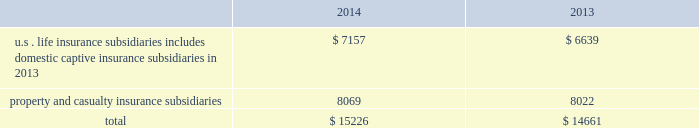The agencies consider many factors in determining the final rating of an insurance company .
One consideration is the relative level of statutory surplus necessary to support the business written .
Statutory surplus represents the capital of the insurance company reported in accordance with accounting practices prescribed by the applicable state insurance department .
See part i , item 1a .
Risk factors 2014 201cdowngrades in our financial strength or credit ratings , which may make our products less attractive , could increase our cost of capital and inhibit our ability to refinance our debt , which would have a material adverse effect on our business , financial condition , results of operations and liquidity . 201d statutory surplus the table below sets forth statutory surplus for the company 2019s insurance companies as of december 31 , 2014 and 2013: .
Statutory capital and surplus for the u.s .
Life insurance subsidiaries , including domestic captive insurance subsidiaries in 2013 , increased by $ 518 , primarily due to variable annuity surplus impacts of $ 788 , net income from non-variable annuity business of $ 187 , increases in unrealized gains from other invested assets carrying values of $ 138 , partially offset by returns of capital of $ 500 , and changes in reserves on account of change in valuation basis of $ 100 .
Effective april 30 , 2014 the last domestic captive ceased operations .
Statutory capital and surplus for the property and casualty insurance increased by $ 47 , primarily due to statutory net income of $ 1.1 billion , and unrealized gains on investments of $ 1.4 billion , largely offset by dividends to the hfsg holding company of $ 2.5 billion .
The company also held regulatory capital and surplus for its former operations in japan until the sale of those operations on june 30 , 2014 .
Under the accounting practices and procedures governed by japanese regulatory authorities , the company 2019s statutory capital and surplus was $ 1.2 billion as of december 31 , 2013. .
What portion of the total statutory surplus is related to property and casualty insurance subsidiaries in 2014? 
Computations: (8069 / 15226)
Answer: 0.52995. 